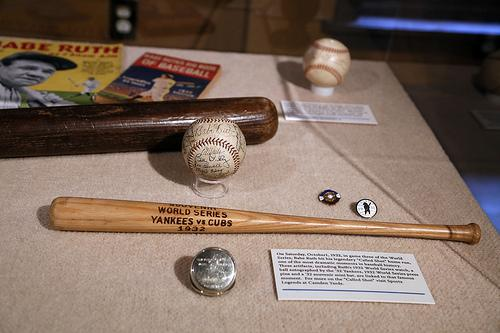Question: why is there writing on the bat?
Choices:
A. Commemoration.
B. The manufacturer.
C. So the players know which one is theirs.
D. A child wrote on it.
Answer with the letter. Answer: A Question: who is featured on the yellow magazine?
Choices:
A. Brad Pitt.
B. Babe Ruth.
C. Derek Jeter.
D. Lebron James.
Answer with the letter. Answer: B Question: what are the bats made of?
Choices:
A. Wood.
B. Aluminum.
C. Plastic.
D. Foam.
Answer with the letter. Answer: A Question: what color is the table?
Choices:
A. Beige.
B. Black.
C. Tan.
D. Red.
Answer with the letter. Answer: A 